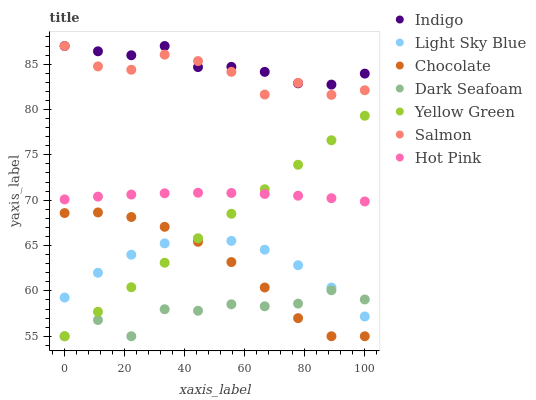Does Dark Seafoam have the minimum area under the curve?
Answer yes or no. Yes. Does Indigo have the maximum area under the curve?
Answer yes or no. Yes. Does Yellow Green have the minimum area under the curve?
Answer yes or no. No. Does Yellow Green have the maximum area under the curve?
Answer yes or no. No. Is Yellow Green the smoothest?
Answer yes or no. Yes. Is Dark Seafoam the roughest?
Answer yes or no. Yes. Is Hot Pink the smoothest?
Answer yes or no. No. Is Hot Pink the roughest?
Answer yes or no. No. Does Yellow Green have the lowest value?
Answer yes or no. Yes. Does Hot Pink have the lowest value?
Answer yes or no. No. Does Salmon have the highest value?
Answer yes or no. Yes. Does Yellow Green have the highest value?
Answer yes or no. No. Is Chocolate less than Indigo?
Answer yes or no. Yes. Is Salmon greater than Yellow Green?
Answer yes or no. Yes. Does Dark Seafoam intersect Yellow Green?
Answer yes or no. Yes. Is Dark Seafoam less than Yellow Green?
Answer yes or no. No. Is Dark Seafoam greater than Yellow Green?
Answer yes or no. No. Does Chocolate intersect Indigo?
Answer yes or no. No. 